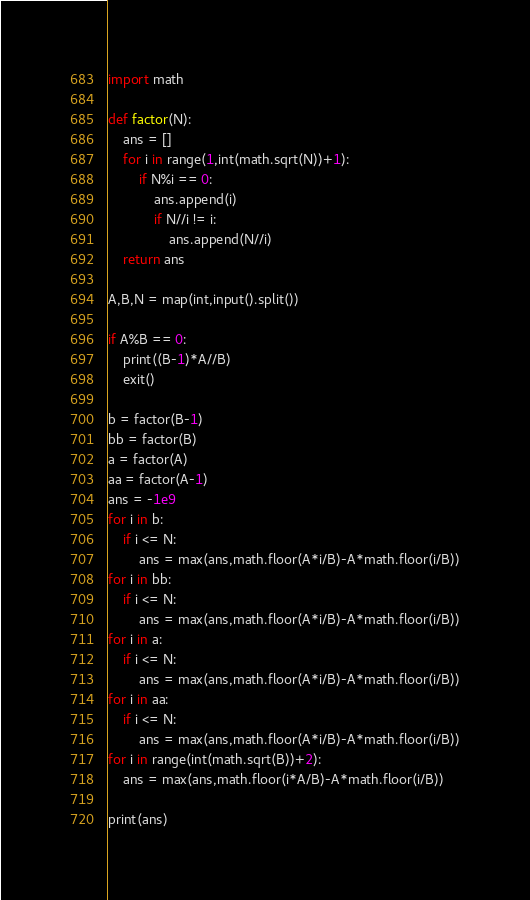<code> <loc_0><loc_0><loc_500><loc_500><_Python_>import math

def factor(N):
    ans = []
    for i in range(1,int(math.sqrt(N))+1):
        if N%i == 0:
            ans.append(i)
            if N//i != i:
                ans.append(N//i)
    return ans

A,B,N = map(int,input().split())

if A%B == 0:
    print((B-1)*A//B)
    exit()

b = factor(B-1)
bb = factor(B)
a = factor(A)
aa = factor(A-1)
ans = -1e9
for i in b:
    if i <= N:
        ans = max(ans,math.floor(A*i/B)-A*math.floor(i/B))
for i in bb:
    if i <= N:
        ans = max(ans,math.floor(A*i/B)-A*math.floor(i/B))
for i in a:
    if i <= N:
        ans = max(ans,math.floor(A*i/B)-A*math.floor(i/B))
for i in aa:
    if i <= N:
        ans = max(ans,math.floor(A*i/B)-A*math.floor(i/B))
for i in range(int(math.sqrt(B))+2):
    ans = max(ans,math.floor(i*A/B)-A*math.floor(i/B))

print(ans)</code> 